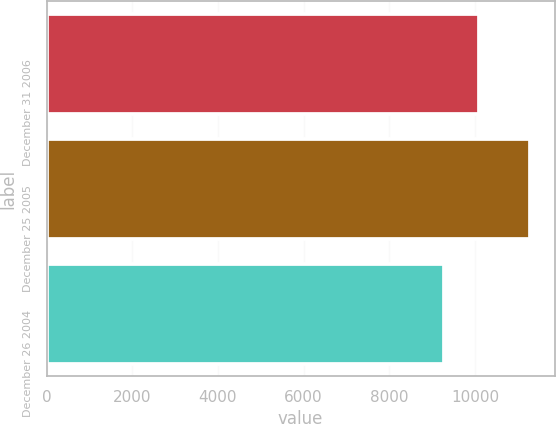Convert chart to OTSL. <chart><loc_0><loc_0><loc_500><loc_500><bar_chart><fcel>December 31 2006<fcel>December 25 2005<fcel>December 26 2004<nl><fcel>10090<fcel>11296<fcel>9273<nl></chart> 